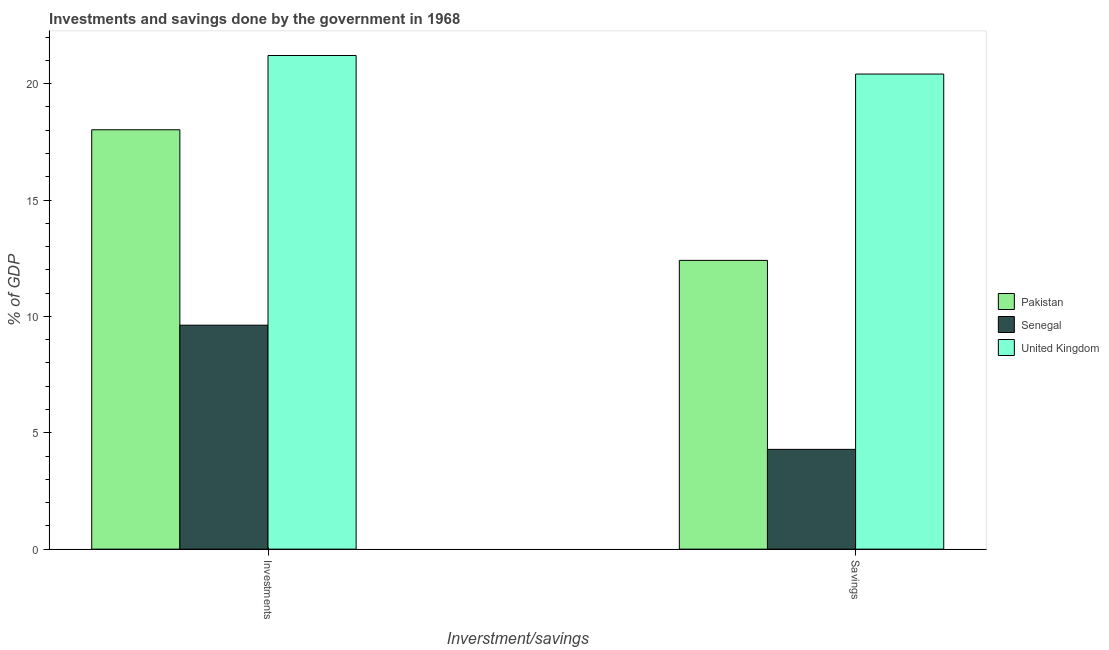Are the number of bars per tick equal to the number of legend labels?
Your answer should be very brief. Yes. How many bars are there on the 1st tick from the right?
Make the answer very short. 3. What is the label of the 1st group of bars from the left?
Your answer should be compact. Investments. What is the investments of government in Senegal?
Offer a very short reply. 9.62. Across all countries, what is the maximum investments of government?
Your response must be concise. 21.21. Across all countries, what is the minimum investments of government?
Your answer should be very brief. 9.62. In which country was the savings of government maximum?
Provide a short and direct response. United Kingdom. In which country was the investments of government minimum?
Your answer should be very brief. Senegal. What is the total investments of government in the graph?
Ensure brevity in your answer.  48.85. What is the difference between the savings of government in Senegal and that in Pakistan?
Keep it short and to the point. -8.12. What is the difference between the savings of government in Senegal and the investments of government in Pakistan?
Give a very brief answer. -13.73. What is the average investments of government per country?
Ensure brevity in your answer.  16.28. What is the difference between the investments of government and savings of government in Pakistan?
Give a very brief answer. 5.61. In how many countries, is the investments of government greater than 16 %?
Provide a succinct answer. 2. What is the ratio of the savings of government in Pakistan to that in Senegal?
Your response must be concise. 2.89. In how many countries, is the investments of government greater than the average investments of government taken over all countries?
Make the answer very short. 2. What does the 1st bar from the right in Investments represents?
Ensure brevity in your answer.  United Kingdom. How many bars are there?
Ensure brevity in your answer.  6. Are the values on the major ticks of Y-axis written in scientific E-notation?
Ensure brevity in your answer.  No. Does the graph contain grids?
Provide a succinct answer. No. How many legend labels are there?
Give a very brief answer. 3. What is the title of the graph?
Provide a succinct answer. Investments and savings done by the government in 1968. Does "Curacao" appear as one of the legend labels in the graph?
Your answer should be compact. No. What is the label or title of the X-axis?
Offer a terse response. Inverstment/savings. What is the label or title of the Y-axis?
Provide a short and direct response. % of GDP. What is the % of GDP of Pakistan in Investments?
Provide a short and direct response. 18.02. What is the % of GDP of Senegal in Investments?
Provide a succinct answer. 9.62. What is the % of GDP in United Kingdom in Investments?
Your response must be concise. 21.21. What is the % of GDP of Pakistan in Savings?
Provide a short and direct response. 12.41. What is the % of GDP in Senegal in Savings?
Provide a short and direct response. 4.29. What is the % of GDP in United Kingdom in Savings?
Offer a terse response. 20.41. Across all Inverstment/savings, what is the maximum % of GDP of Pakistan?
Offer a very short reply. 18.02. Across all Inverstment/savings, what is the maximum % of GDP in Senegal?
Your response must be concise. 9.62. Across all Inverstment/savings, what is the maximum % of GDP in United Kingdom?
Ensure brevity in your answer.  21.21. Across all Inverstment/savings, what is the minimum % of GDP of Pakistan?
Make the answer very short. 12.41. Across all Inverstment/savings, what is the minimum % of GDP of Senegal?
Your response must be concise. 4.29. Across all Inverstment/savings, what is the minimum % of GDP of United Kingdom?
Provide a succinct answer. 20.41. What is the total % of GDP in Pakistan in the graph?
Ensure brevity in your answer.  30.43. What is the total % of GDP in Senegal in the graph?
Your response must be concise. 13.91. What is the total % of GDP of United Kingdom in the graph?
Ensure brevity in your answer.  41.62. What is the difference between the % of GDP in Pakistan in Investments and that in Savings?
Give a very brief answer. 5.61. What is the difference between the % of GDP in Senegal in Investments and that in Savings?
Your answer should be very brief. 5.34. What is the difference between the % of GDP of United Kingdom in Investments and that in Savings?
Your answer should be very brief. 0.8. What is the difference between the % of GDP in Pakistan in Investments and the % of GDP in Senegal in Savings?
Offer a very short reply. 13.73. What is the difference between the % of GDP in Pakistan in Investments and the % of GDP in United Kingdom in Savings?
Your answer should be very brief. -2.39. What is the difference between the % of GDP in Senegal in Investments and the % of GDP in United Kingdom in Savings?
Provide a succinct answer. -10.79. What is the average % of GDP of Pakistan per Inverstment/savings?
Your answer should be very brief. 15.21. What is the average % of GDP of Senegal per Inverstment/savings?
Keep it short and to the point. 6.96. What is the average % of GDP of United Kingdom per Inverstment/savings?
Your answer should be very brief. 20.81. What is the difference between the % of GDP of Pakistan and % of GDP of Senegal in Investments?
Your answer should be compact. 8.4. What is the difference between the % of GDP in Pakistan and % of GDP in United Kingdom in Investments?
Your answer should be compact. -3.19. What is the difference between the % of GDP of Senegal and % of GDP of United Kingdom in Investments?
Provide a succinct answer. -11.59. What is the difference between the % of GDP in Pakistan and % of GDP in Senegal in Savings?
Offer a very short reply. 8.12. What is the difference between the % of GDP of Pakistan and % of GDP of United Kingdom in Savings?
Ensure brevity in your answer.  -8.01. What is the difference between the % of GDP in Senegal and % of GDP in United Kingdom in Savings?
Ensure brevity in your answer.  -16.13. What is the ratio of the % of GDP of Pakistan in Investments to that in Savings?
Ensure brevity in your answer.  1.45. What is the ratio of the % of GDP in Senegal in Investments to that in Savings?
Provide a succinct answer. 2.24. What is the ratio of the % of GDP of United Kingdom in Investments to that in Savings?
Provide a succinct answer. 1.04. What is the difference between the highest and the second highest % of GDP in Pakistan?
Give a very brief answer. 5.61. What is the difference between the highest and the second highest % of GDP in Senegal?
Offer a terse response. 5.34. What is the difference between the highest and the second highest % of GDP of United Kingdom?
Your answer should be compact. 0.8. What is the difference between the highest and the lowest % of GDP in Pakistan?
Your response must be concise. 5.61. What is the difference between the highest and the lowest % of GDP of Senegal?
Your answer should be compact. 5.34. What is the difference between the highest and the lowest % of GDP in United Kingdom?
Offer a very short reply. 0.8. 